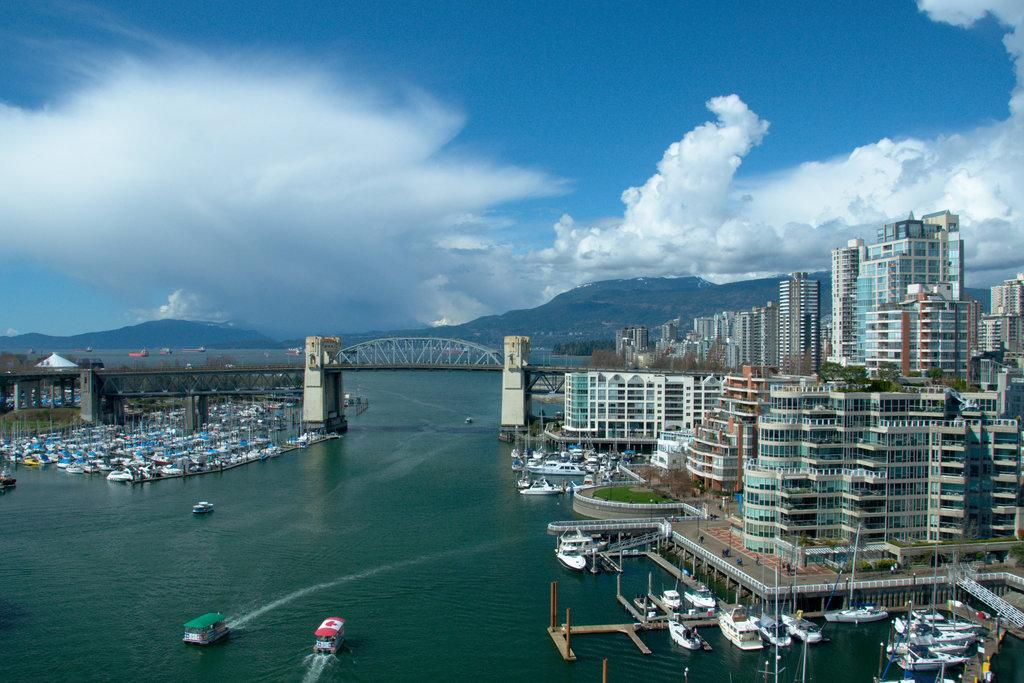What type of vehicles can be seen on the water in the image? There are boats on the water in the image. What structures are present in the image? There are buildings in the image. What type of vegetation is visible in the image? There are trees in the image. What architectural feature connects the two sides of the water in the image? There is a bridge in the image. What type of natural landform can be seen in the image? There are hills in the image. What is visible in the background of the image? The sky is visible in the background of the image. How many apples are hanging from the trees in the image? There are no apples visible in the image; only trees are present. What type of experience can be gained from riding the bikes in the image? There are no bikes present in the image, so no such experience can be gained. 